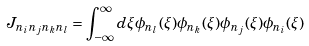Convert formula to latex. <formula><loc_0><loc_0><loc_500><loc_500>J _ { n _ { i } n _ { j } n _ { k } n _ { l } } = \int _ { - \infty } ^ { \infty } d \xi \phi _ { n _ { l } } ( \xi ) \phi _ { n _ { k } } ( \xi ) \phi _ { n _ { j } } ( \xi ) \phi _ { n _ { i } } ( \xi )</formula> 